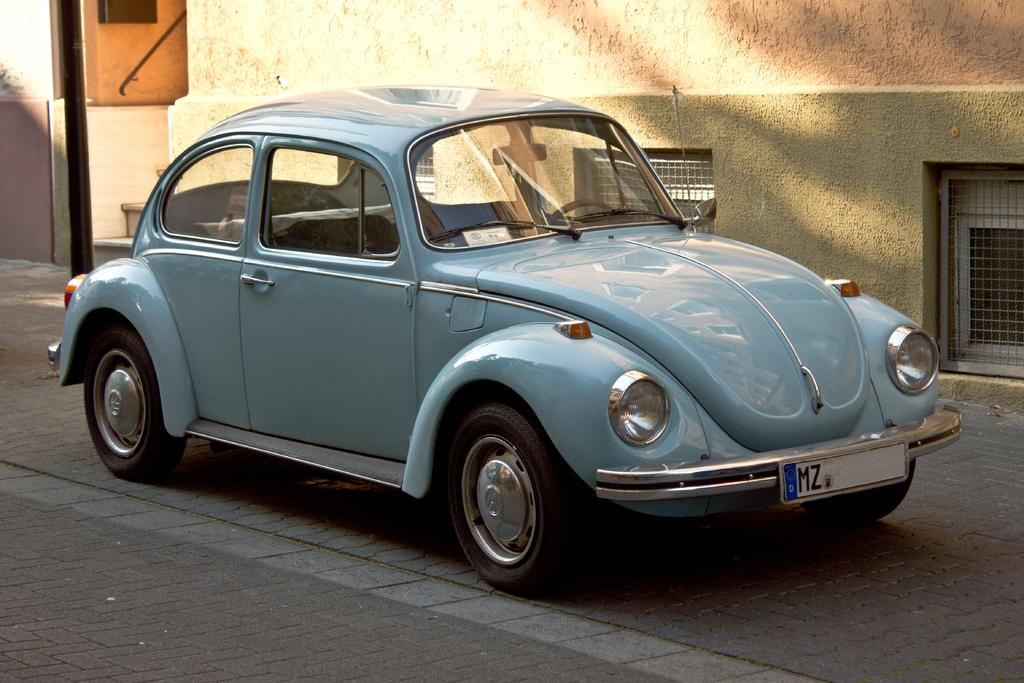What is the main subject of the image? There is a car in the image. Where is the car located? The car is on the road. What can be seen in the background of the image? There is a building in the background of the image. Is the car stuck in quicksand in the image? No, there is no quicksand present in the image. The car is on the road, not in quicksand. 